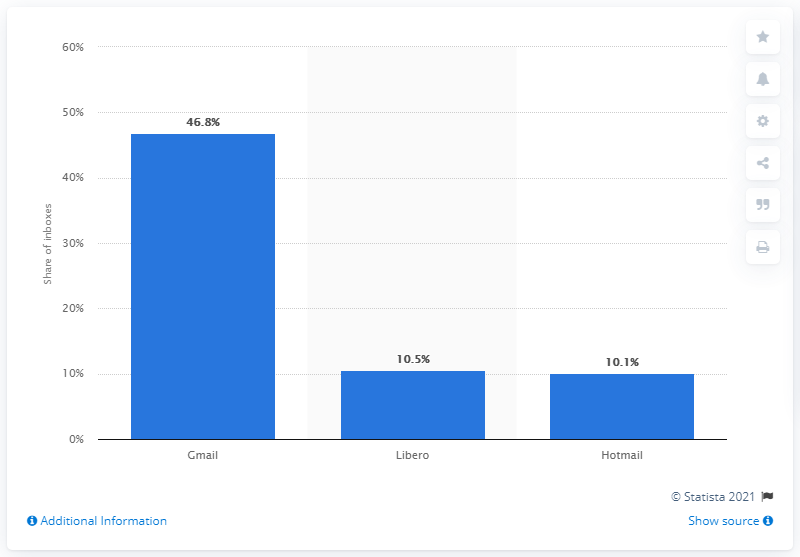Identify some key points in this picture. In 2018, Libero was the leading e-mail provider in Italy. In 2018, Gmail was the most popular e-mail provider in Italy. 